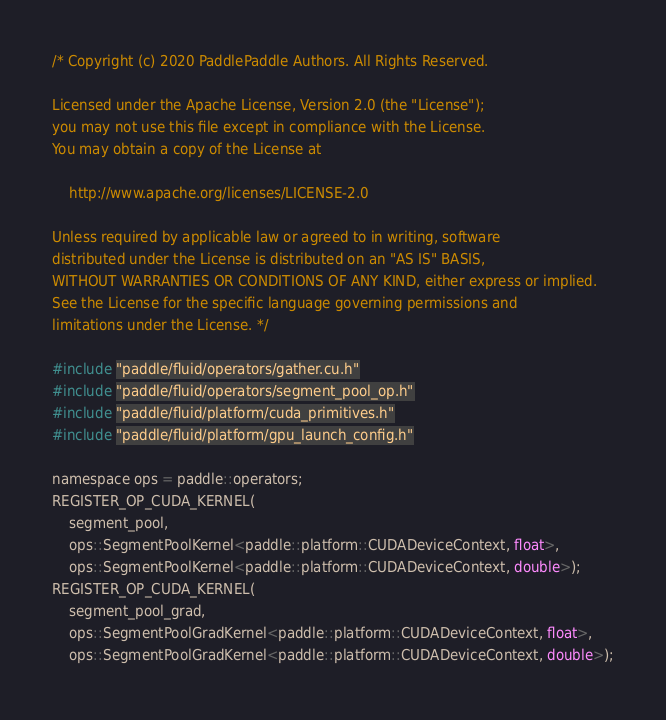<code> <loc_0><loc_0><loc_500><loc_500><_Cuda_>/* Copyright (c) 2020 PaddlePaddle Authors. All Rights Reserved.

Licensed under the Apache License, Version 2.0 (the "License");
you may not use this file except in compliance with the License.
You may obtain a copy of the License at

    http://www.apache.org/licenses/LICENSE-2.0

Unless required by applicable law or agreed to in writing, software
distributed under the License is distributed on an "AS IS" BASIS,
WITHOUT WARRANTIES OR CONDITIONS OF ANY KIND, either express or implied.
See the License for the specific language governing permissions and
limitations under the License. */

#include "paddle/fluid/operators/gather.cu.h"
#include "paddle/fluid/operators/segment_pool_op.h"
#include "paddle/fluid/platform/cuda_primitives.h"
#include "paddle/fluid/platform/gpu_launch_config.h"

namespace ops = paddle::operators;
REGISTER_OP_CUDA_KERNEL(
    segment_pool,
    ops::SegmentPoolKernel<paddle::platform::CUDADeviceContext, float>,
    ops::SegmentPoolKernel<paddle::platform::CUDADeviceContext, double>);
REGISTER_OP_CUDA_KERNEL(
    segment_pool_grad,
    ops::SegmentPoolGradKernel<paddle::platform::CUDADeviceContext, float>,
    ops::SegmentPoolGradKernel<paddle::platform::CUDADeviceContext, double>);
</code> 